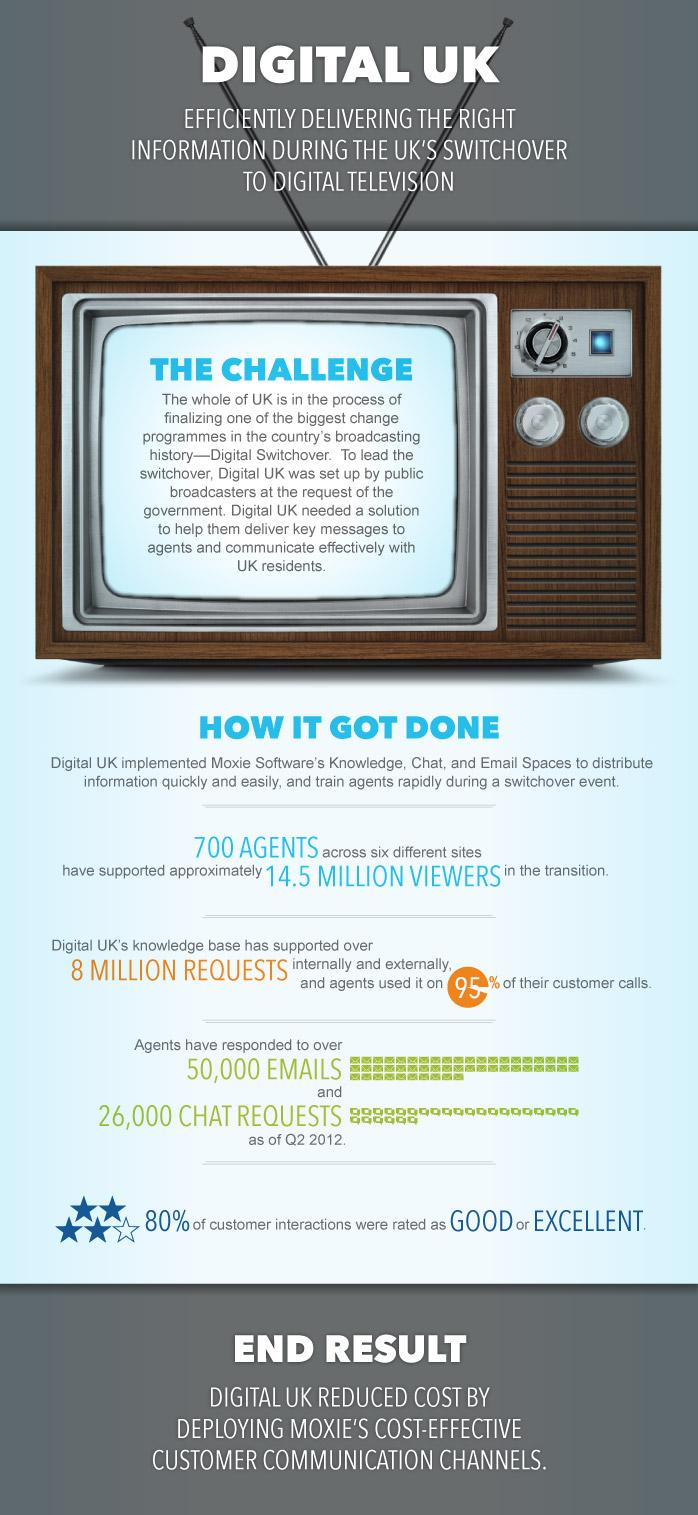Draw attention to some important aspects in this diagram. The color of the text "end result" is white. The number of responses given through mail and chat differs by approximately 24,000. There are five star symbols located near the text "80%. The color of heading text is either white or black. The percentage of customer interactions that were not rated as good or excellent was 20%. 